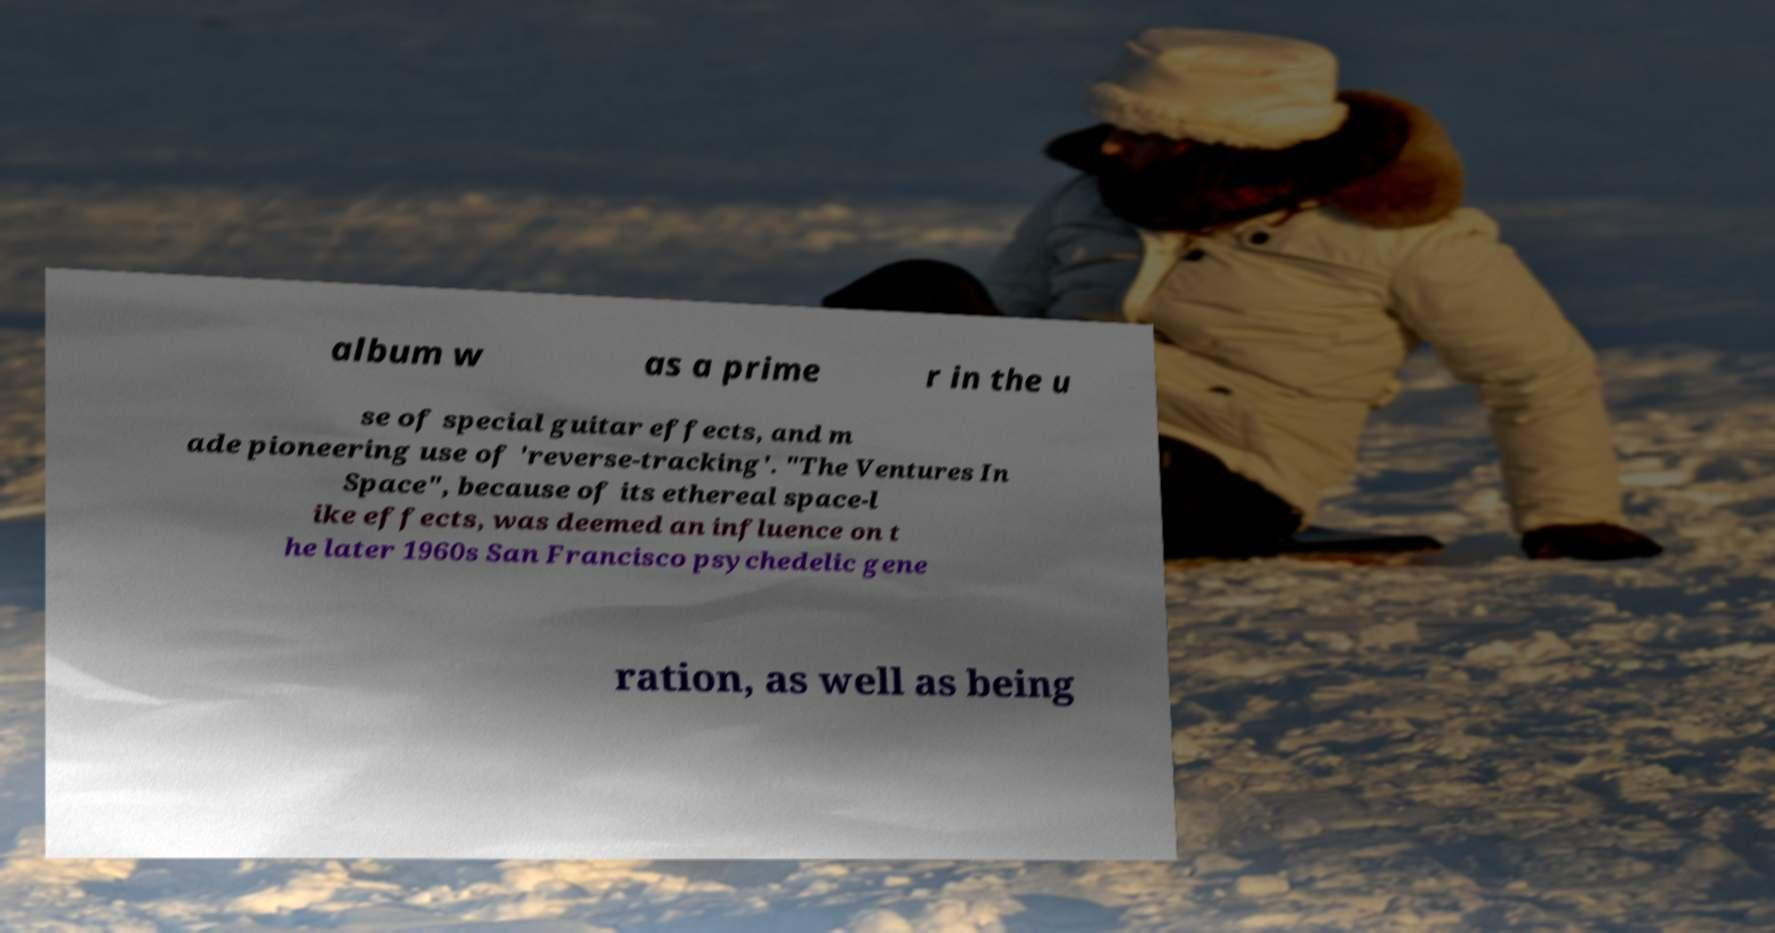Can you read and provide the text displayed in the image?This photo seems to have some interesting text. Can you extract and type it out for me? album w as a prime r in the u se of special guitar effects, and m ade pioneering use of 'reverse-tracking'. "The Ventures In Space", because of its ethereal space-l ike effects, was deemed an influence on t he later 1960s San Francisco psychedelic gene ration, as well as being 